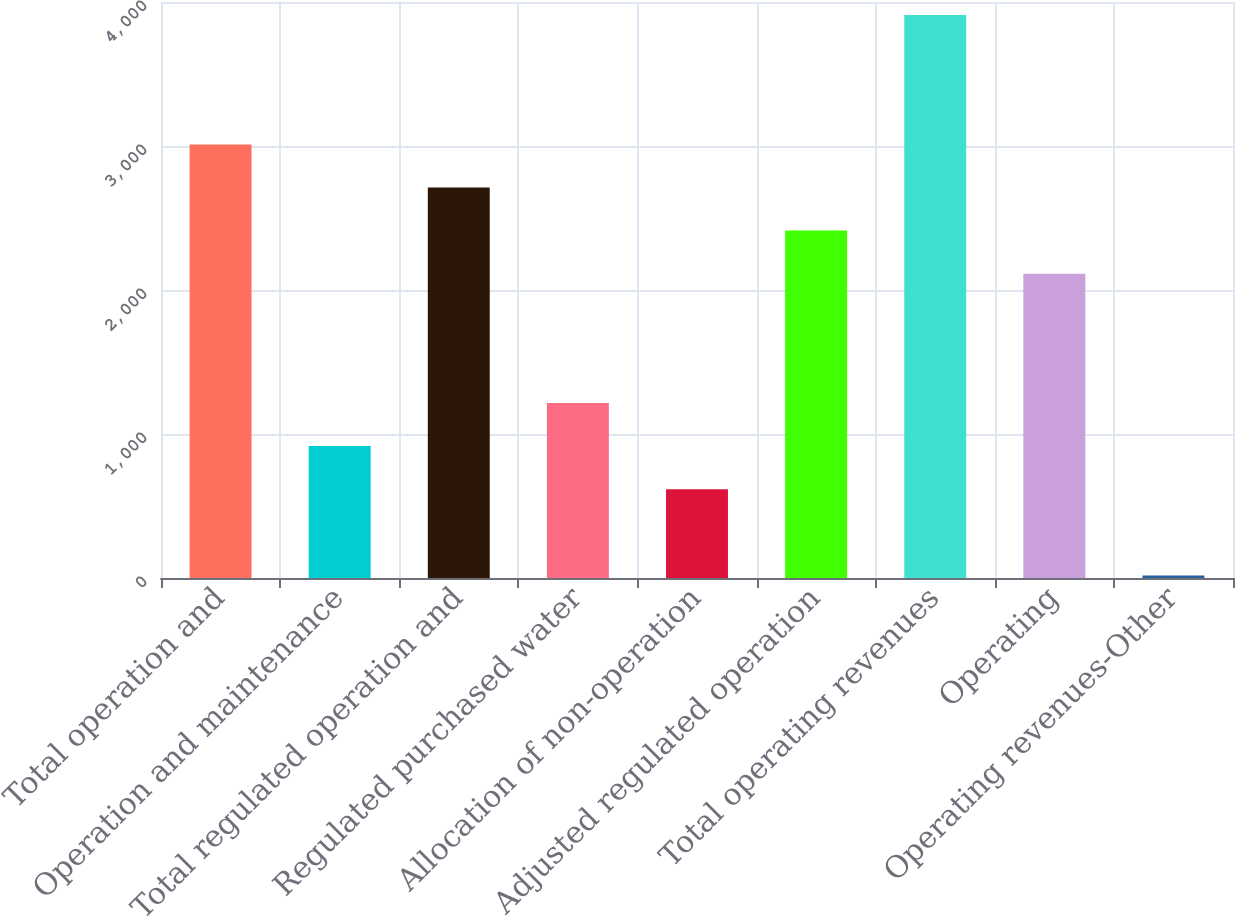Convert chart. <chart><loc_0><loc_0><loc_500><loc_500><bar_chart><fcel>Total operation and<fcel>Operation and maintenance<fcel>Total regulated operation and<fcel>Regulated purchased water<fcel>Allocation of non-operation<fcel>Adjusted regulated operation<fcel>Total operating revenues<fcel>Operating<fcel>Operating revenues-Other<nl><fcel>3011<fcel>915.9<fcel>2711.7<fcel>1215.2<fcel>616.6<fcel>2412.4<fcel>3908.9<fcel>2113.1<fcel>18<nl></chart> 